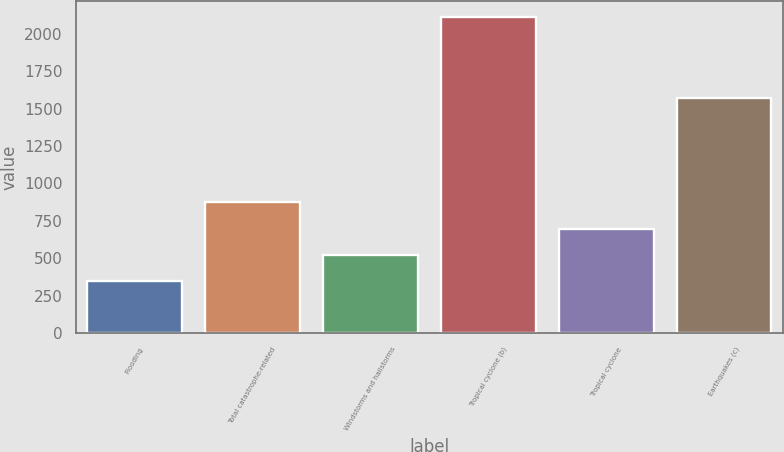Convert chart to OTSL. <chart><loc_0><loc_0><loc_500><loc_500><bar_chart><fcel>Flooding<fcel>Total catastrophe-related<fcel>Windstorms and hailstorms<fcel>Tropical cyclone (b)<fcel>Tropical cyclone<fcel>Earthquakes (c)<nl><fcel>345<fcel>875.1<fcel>521.7<fcel>2112<fcel>698.4<fcel>1568<nl></chart> 